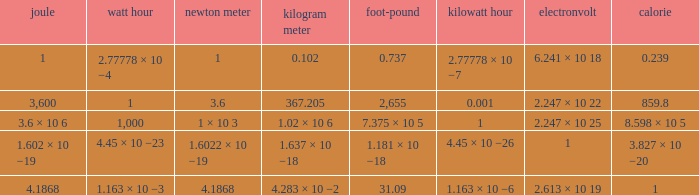How many electronvolts is 3,600 joules? 2.247 × 10 22. 